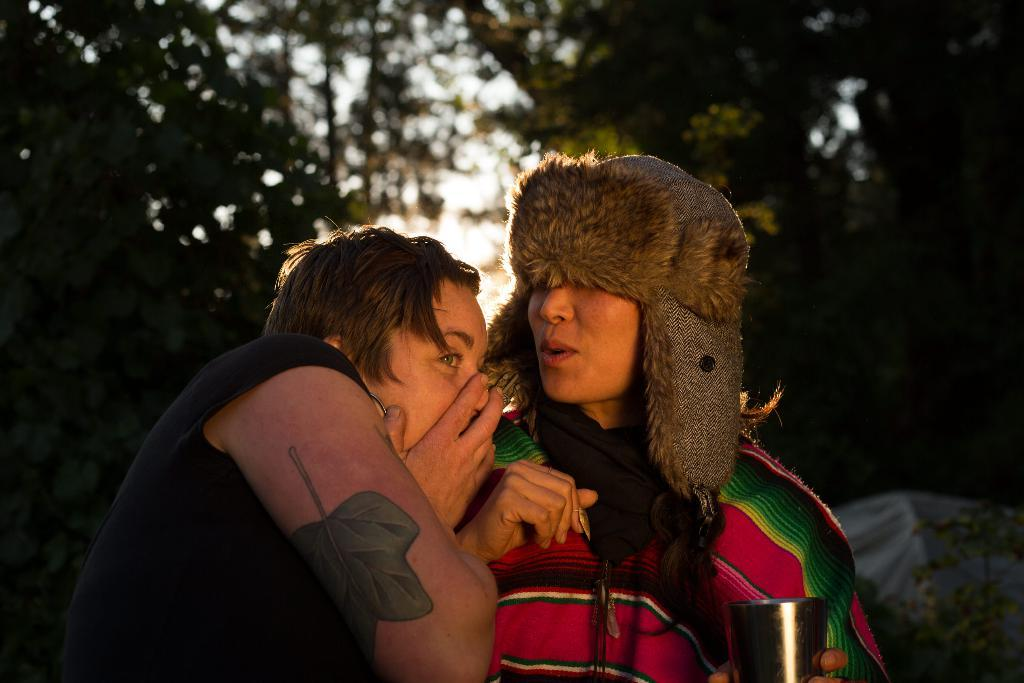How many people are in the image? There are two people in the image. What is distinctive about one of the people's appearance? One of the people is wearing something on their head. What is the person with something on their head holding? The person with something on their head is holding a glass. What type of vegetation can be seen in the image? Plants and trees are visible in the image. What type of boat can be seen in the image? There is no boat present in the image. What color is the copper flag in the image? There is no copper flag present in the image. 